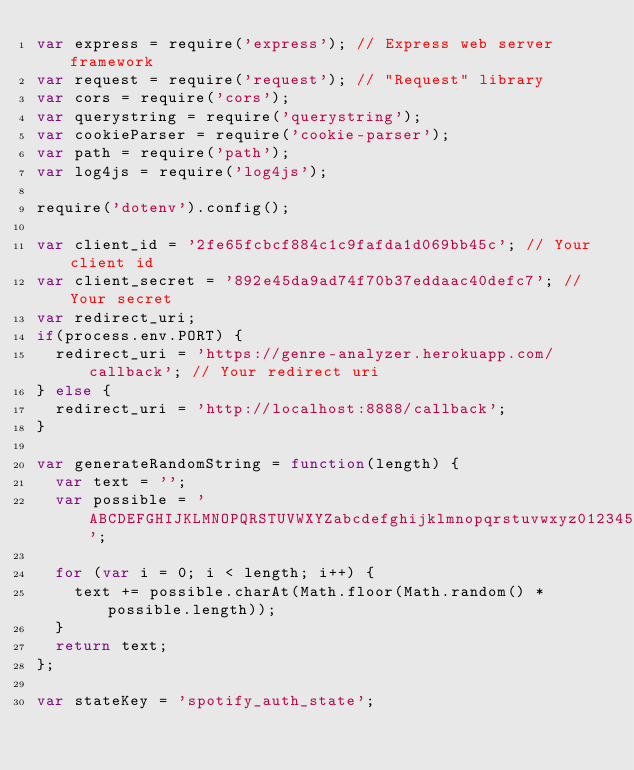<code> <loc_0><loc_0><loc_500><loc_500><_JavaScript_>var express = require('express'); // Express web server framework
var request = require('request'); // "Request" library
var cors = require('cors');
var querystring = require('querystring');
var cookieParser = require('cookie-parser');
var path = require('path');
var log4js = require('log4js');

require('dotenv').config();

var client_id = '2fe65fcbcf884c1c9fafda1d069bb45c'; // Your client id
var client_secret = '892e45da9ad74f70b37eddaac40defc7'; // Your secret
var redirect_uri;
if(process.env.PORT) {
  redirect_uri = 'https://genre-analyzer.herokuapp.com/callback'; // Your redirect uri
} else {
  redirect_uri = 'http://localhost:8888/callback';
}

var generateRandomString = function(length) {
  var text = '';
  var possible = 'ABCDEFGHIJKLMNOPQRSTUVWXYZabcdefghijklmnopqrstuvwxyz0123456789';

  for (var i = 0; i < length; i++) {
    text += possible.charAt(Math.floor(Math.random() * possible.length));
  }
  return text;
};

var stateKey = 'spotify_auth_state';
</code> 